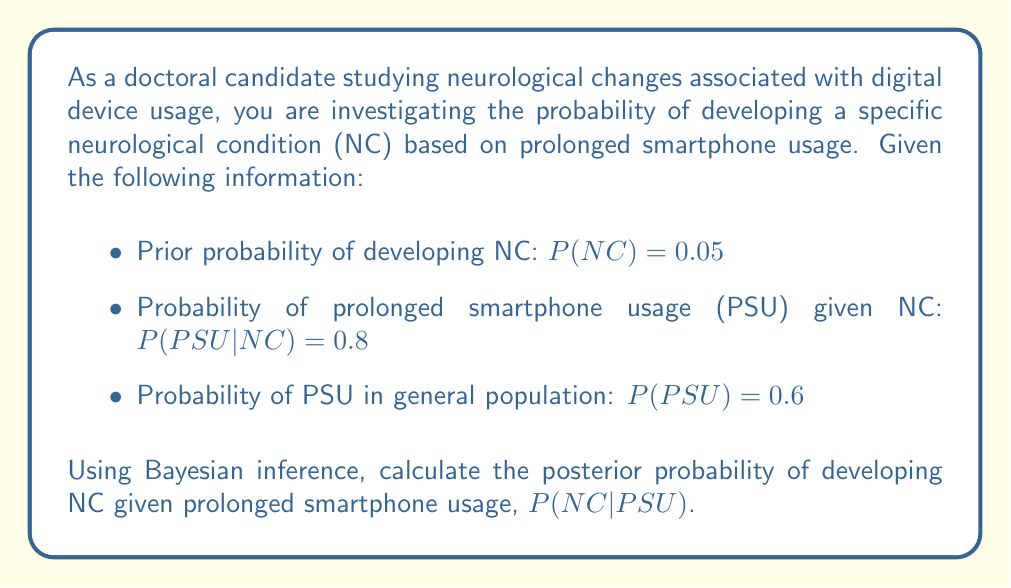Help me with this question. To solve this problem, we'll use Bayes' theorem, which is given by:

$$P(A|B) = \frac{P(B|A) \cdot P(A)}{P(B)}$$

In our case:
A = NC (Neurological Condition)
B = PSU (Prolonged Smartphone Usage)

We want to find $P(NC|PSU)$, and we're given:
$P(NC) = 0.05$
$P(PSU|NC) = 0.8$
$P(PSU) = 0.6$

Step 1: Apply Bayes' theorem
$$P(NC|PSU) = \frac{P(PSU|NC) \cdot P(NC)}{P(PSU)}$$

Step 2: Substitute the known values
$$P(NC|PSU) = \frac{0.8 \cdot 0.05}{0.6}$$

Step 3: Calculate the result
$$P(NC|PSU) = \frac{0.04}{0.6} = \frac{2}{30} = \frac{1}{15} \approx 0.0667$$

Therefore, the posterior probability of developing the neurological condition given prolonged smartphone usage is approximately 0.0667 or 6.67%.
Answer: $P(NC|PSU) = \frac{1}{15} \approx 0.0667$ or 6.67% 